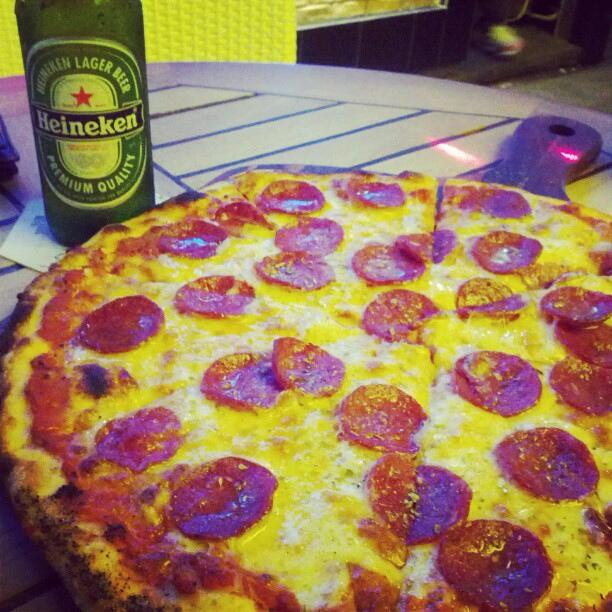Is the pizza on a board?
Give a very brief answer. Yes. What's in the bottles?
Be succinct. Beer. What kind of pizza is in the picture?
Keep it brief. Pepperoni. Is there tomato slices on the pizza?
Be succinct. No. How many pepperoni are on the pizza?
Quick response, please. 24. What's the name of the beer?
Write a very short answer. Heineken. 